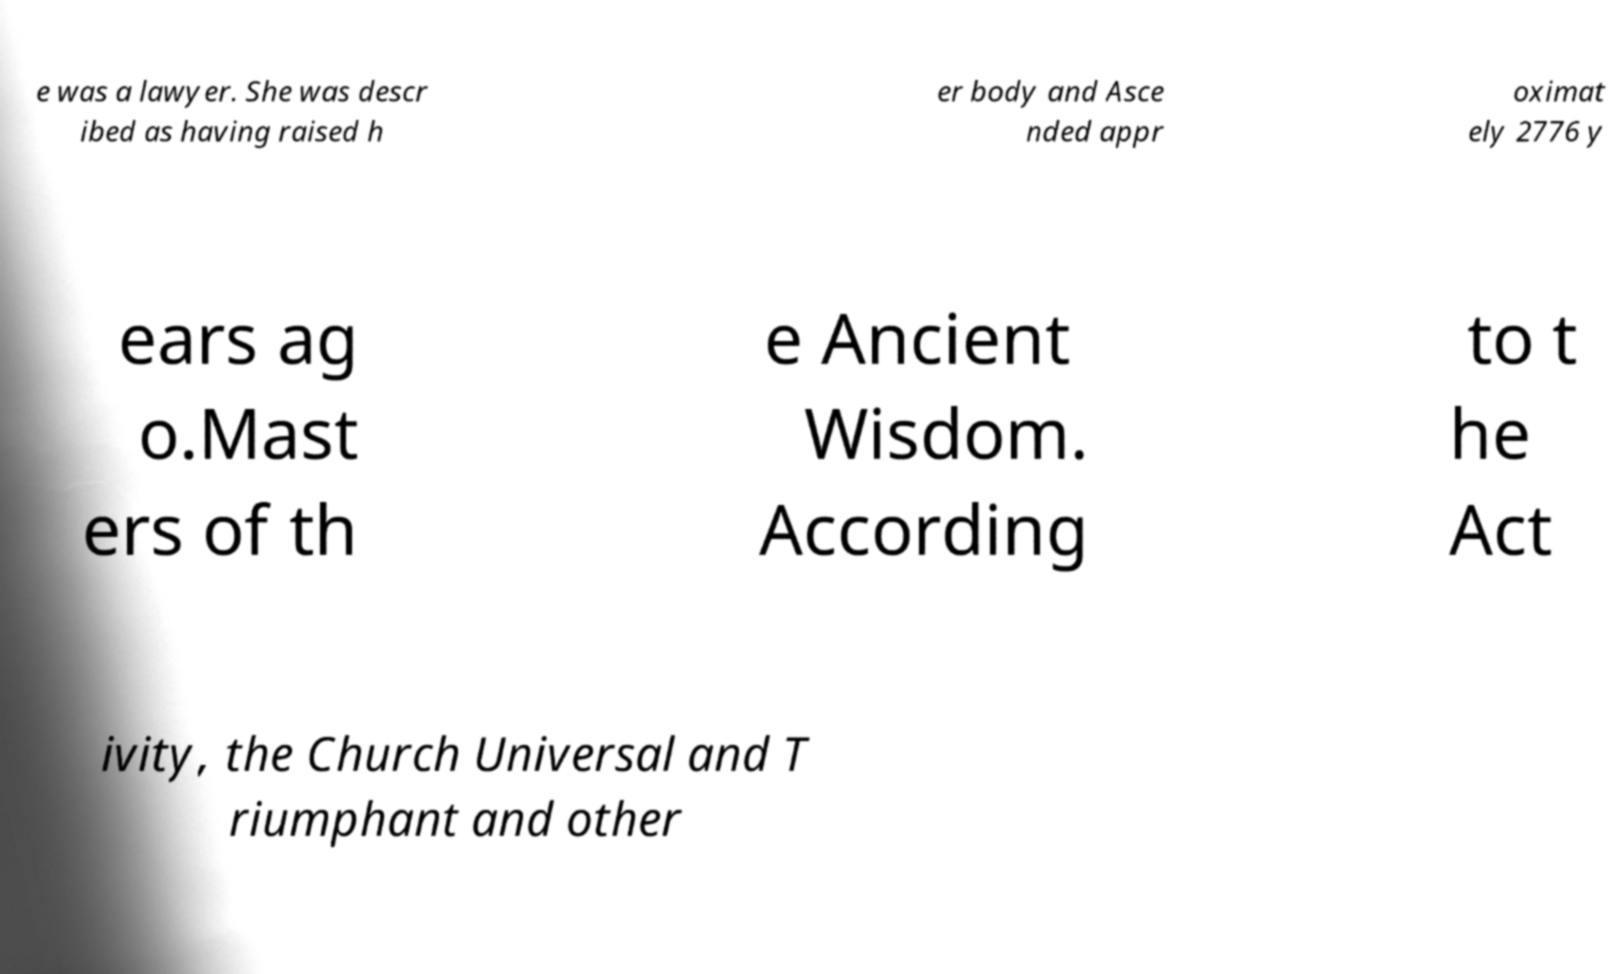What messages or text are displayed in this image? I need them in a readable, typed format. e was a lawyer. She was descr ibed as having raised h er body and Asce nded appr oximat ely 2776 y ears ag o.Mast ers of th e Ancient Wisdom. According to t he Act ivity, the Church Universal and T riumphant and other 